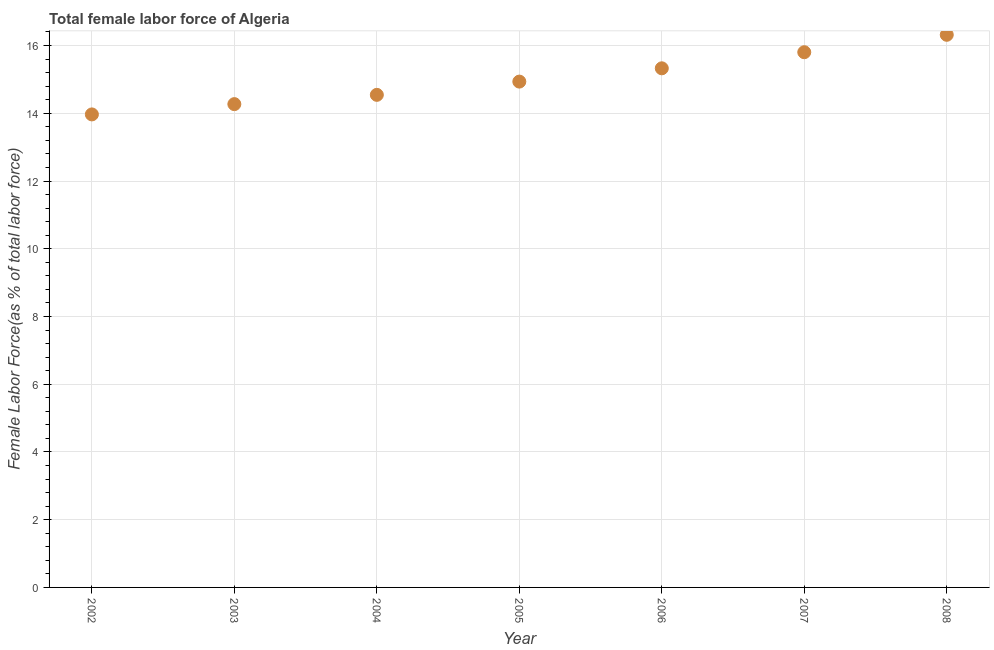What is the total female labor force in 2005?
Your answer should be compact. 14.94. Across all years, what is the maximum total female labor force?
Offer a very short reply. 16.32. Across all years, what is the minimum total female labor force?
Your answer should be compact. 13.97. In which year was the total female labor force maximum?
Offer a very short reply. 2008. What is the sum of the total female labor force?
Give a very brief answer. 105.16. What is the difference between the total female labor force in 2005 and 2006?
Ensure brevity in your answer.  -0.39. What is the average total female labor force per year?
Your response must be concise. 15.02. What is the median total female labor force?
Your answer should be very brief. 14.94. Do a majority of the years between 2003 and 2006 (inclusive) have total female labor force greater than 7.2 %?
Provide a succinct answer. Yes. What is the ratio of the total female labor force in 2002 to that in 2003?
Your answer should be very brief. 0.98. Is the total female labor force in 2003 less than that in 2005?
Ensure brevity in your answer.  Yes. Is the difference between the total female labor force in 2003 and 2005 greater than the difference between any two years?
Provide a short and direct response. No. What is the difference between the highest and the second highest total female labor force?
Offer a terse response. 0.51. Is the sum of the total female labor force in 2005 and 2006 greater than the maximum total female labor force across all years?
Offer a terse response. Yes. What is the difference between the highest and the lowest total female labor force?
Your answer should be compact. 2.35. How many dotlines are there?
Your answer should be very brief. 1. How many years are there in the graph?
Your answer should be compact. 7. Are the values on the major ticks of Y-axis written in scientific E-notation?
Keep it short and to the point. No. Does the graph contain any zero values?
Offer a terse response. No. Does the graph contain grids?
Your answer should be compact. Yes. What is the title of the graph?
Provide a short and direct response. Total female labor force of Algeria. What is the label or title of the Y-axis?
Keep it short and to the point. Female Labor Force(as % of total labor force). What is the Female Labor Force(as % of total labor force) in 2002?
Keep it short and to the point. 13.97. What is the Female Labor Force(as % of total labor force) in 2003?
Your answer should be very brief. 14.27. What is the Female Labor Force(as % of total labor force) in 2004?
Offer a terse response. 14.54. What is the Female Labor Force(as % of total labor force) in 2005?
Your answer should be very brief. 14.94. What is the Female Labor Force(as % of total labor force) in 2006?
Keep it short and to the point. 15.33. What is the Female Labor Force(as % of total labor force) in 2007?
Your answer should be compact. 15.8. What is the Female Labor Force(as % of total labor force) in 2008?
Your answer should be compact. 16.32. What is the difference between the Female Labor Force(as % of total labor force) in 2002 and 2003?
Offer a terse response. -0.3. What is the difference between the Female Labor Force(as % of total labor force) in 2002 and 2004?
Give a very brief answer. -0.58. What is the difference between the Female Labor Force(as % of total labor force) in 2002 and 2005?
Ensure brevity in your answer.  -0.97. What is the difference between the Female Labor Force(as % of total labor force) in 2002 and 2006?
Keep it short and to the point. -1.36. What is the difference between the Female Labor Force(as % of total labor force) in 2002 and 2007?
Provide a succinct answer. -1.84. What is the difference between the Female Labor Force(as % of total labor force) in 2002 and 2008?
Give a very brief answer. -2.35. What is the difference between the Female Labor Force(as % of total labor force) in 2003 and 2004?
Provide a succinct answer. -0.27. What is the difference between the Female Labor Force(as % of total labor force) in 2003 and 2005?
Offer a terse response. -0.66. What is the difference between the Female Labor Force(as % of total labor force) in 2003 and 2006?
Your answer should be very brief. -1.06. What is the difference between the Female Labor Force(as % of total labor force) in 2003 and 2007?
Provide a succinct answer. -1.53. What is the difference between the Female Labor Force(as % of total labor force) in 2003 and 2008?
Offer a very short reply. -2.05. What is the difference between the Female Labor Force(as % of total labor force) in 2004 and 2005?
Offer a terse response. -0.39. What is the difference between the Female Labor Force(as % of total labor force) in 2004 and 2006?
Provide a succinct answer. -0.78. What is the difference between the Female Labor Force(as % of total labor force) in 2004 and 2007?
Make the answer very short. -1.26. What is the difference between the Female Labor Force(as % of total labor force) in 2004 and 2008?
Your response must be concise. -1.77. What is the difference between the Female Labor Force(as % of total labor force) in 2005 and 2006?
Make the answer very short. -0.39. What is the difference between the Female Labor Force(as % of total labor force) in 2005 and 2007?
Offer a terse response. -0.87. What is the difference between the Female Labor Force(as % of total labor force) in 2005 and 2008?
Make the answer very short. -1.38. What is the difference between the Female Labor Force(as % of total labor force) in 2006 and 2007?
Provide a succinct answer. -0.48. What is the difference between the Female Labor Force(as % of total labor force) in 2006 and 2008?
Provide a succinct answer. -0.99. What is the difference between the Female Labor Force(as % of total labor force) in 2007 and 2008?
Provide a succinct answer. -0.51. What is the ratio of the Female Labor Force(as % of total labor force) in 2002 to that in 2004?
Make the answer very short. 0.96. What is the ratio of the Female Labor Force(as % of total labor force) in 2002 to that in 2005?
Make the answer very short. 0.94. What is the ratio of the Female Labor Force(as % of total labor force) in 2002 to that in 2006?
Provide a short and direct response. 0.91. What is the ratio of the Female Labor Force(as % of total labor force) in 2002 to that in 2007?
Your answer should be very brief. 0.88. What is the ratio of the Female Labor Force(as % of total labor force) in 2002 to that in 2008?
Provide a short and direct response. 0.86. What is the ratio of the Female Labor Force(as % of total labor force) in 2003 to that in 2004?
Give a very brief answer. 0.98. What is the ratio of the Female Labor Force(as % of total labor force) in 2003 to that in 2005?
Provide a short and direct response. 0.95. What is the ratio of the Female Labor Force(as % of total labor force) in 2003 to that in 2006?
Provide a succinct answer. 0.93. What is the ratio of the Female Labor Force(as % of total labor force) in 2003 to that in 2007?
Your response must be concise. 0.9. What is the ratio of the Female Labor Force(as % of total labor force) in 2004 to that in 2005?
Give a very brief answer. 0.97. What is the ratio of the Female Labor Force(as % of total labor force) in 2004 to that in 2006?
Your answer should be very brief. 0.95. What is the ratio of the Female Labor Force(as % of total labor force) in 2004 to that in 2008?
Your response must be concise. 0.89. What is the ratio of the Female Labor Force(as % of total labor force) in 2005 to that in 2006?
Your response must be concise. 0.97. What is the ratio of the Female Labor Force(as % of total labor force) in 2005 to that in 2007?
Your answer should be compact. 0.94. What is the ratio of the Female Labor Force(as % of total labor force) in 2005 to that in 2008?
Ensure brevity in your answer.  0.92. What is the ratio of the Female Labor Force(as % of total labor force) in 2006 to that in 2008?
Your answer should be compact. 0.94. What is the ratio of the Female Labor Force(as % of total labor force) in 2007 to that in 2008?
Your response must be concise. 0.97. 